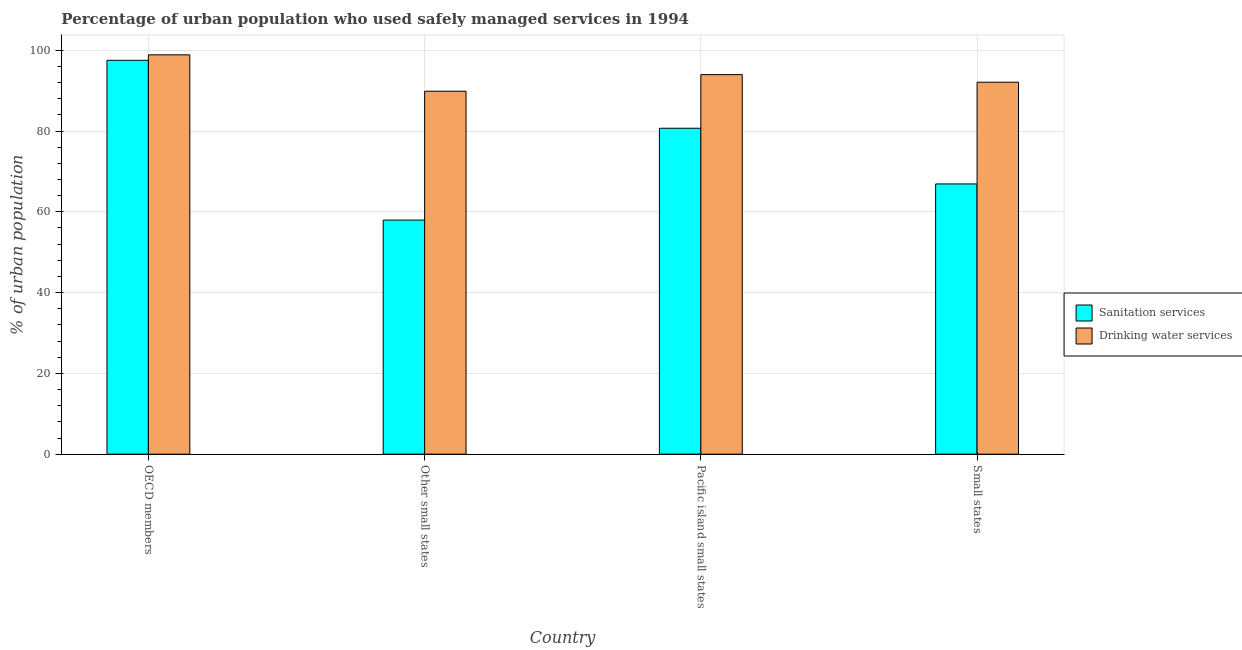Are the number of bars per tick equal to the number of legend labels?
Your answer should be very brief. Yes. Are the number of bars on each tick of the X-axis equal?
Provide a short and direct response. Yes. How many bars are there on the 4th tick from the right?
Provide a succinct answer. 2. What is the label of the 4th group of bars from the left?
Keep it short and to the point. Small states. What is the percentage of urban population who used sanitation services in Other small states?
Your response must be concise. 57.97. Across all countries, what is the maximum percentage of urban population who used drinking water services?
Ensure brevity in your answer.  98.88. Across all countries, what is the minimum percentage of urban population who used drinking water services?
Keep it short and to the point. 89.87. In which country was the percentage of urban population who used drinking water services minimum?
Your answer should be compact. Other small states. What is the total percentage of urban population who used sanitation services in the graph?
Your response must be concise. 303.1. What is the difference between the percentage of urban population who used drinking water services in Pacific island small states and that in Small states?
Give a very brief answer. 1.88. What is the difference between the percentage of urban population who used sanitation services in Small states and the percentage of urban population who used drinking water services in Pacific island small states?
Your answer should be very brief. -27.07. What is the average percentage of urban population who used drinking water services per country?
Make the answer very short. 93.71. What is the difference between the percentage of urban population who used drinking water services and percentage of urban population who used sanitation services in OECD members?
Offer a terse response. 1.35. In how many countries, is the percentage of urban population who used sanitation services greater than 60 %?
Provide a succinct answer. 3. What is the ratio of the percentage of urban population who used sanitation services in OECD members to that in Pacific island small states?
Offer a terse response. 1.21. Is the percentage of urban population who used sanitation services in Other small states less than that in Small states?
Make the answer very short. Yes. Is the difference between the percentage of urban population who used sanitation services in Pacific island small states and Small states greater than the difference between the percentage of urban population who used drinking water services in Pacific island small states and Small states?
Keep it short and to the point. Yes. What is the difference between the highest and the second highest percentage of urban population who used drinking water services?
Provide a succinct answer. 4.9. What is the difference between the highest and the lowest percentage of urban population who used drinking water services?
Give a very brief answer. 9. Is the sum of the percentage of urban population who used drinking water services in OECD members and Other small states greater than the maximum percentage of urban population who used sanitation services across all countries?
Ensure brevity in your answer.  Yes. What does the 2nd bar from the left in Small states represents?
Provide a succinct answer. Drinking water services. What does the 2nd bar from the right in Other small states represents?
Provide a short and direct response. Sanitation services. How many bars are there?
Provide a succinct answer. 8. Are all the bars in the graph horizontal?
Keep it short and to the point. No. How many countries are there in the graph?
Give a very brief answer. 4. Does the graph contain any zero values?
Keep it short and to the point. No. Does the graph contain grids?
Keep it short and to the point. Yes. What is the title of the graph?
Your answer should be very brief. Percentage of urban population who used safely managed services in 1994. What is the label or title of the Y-axis?
Your answer should be compact. % of urban population. What is the % of urban population in Sanitation services in OECD members?
Provide a short and direct response. 97.52. What is the % of urban population of Drinking water services in OECD members?
Make the answer very short. 98.88. What is the % of urban population in Sanitation services in Other small states?
Provide a short and direct response. 57.97. What is the % of urban population of Drinking water services in Other small states?
Offer a very short reply. 89.87. What is the % of urban population in Sanitation services in Pacific island small states?
Offer a very short reply. 80.7. What is the % of urban population in Drinking water services in Pacific island small states?
Offer a terse response. 93.98. What is the % of urban population of Sanitation services in Small states?
Provide a short and direct response. 66.91. What is the % of urban population in Drinking water services in Small states?
Provide a short and direct response. 92.1. Across all countries, what is the maximum % of urban population in Sanitation services?
Provide a succinct answer. 97.52. Across all countries, what is the maximum % of urban population of Drinking water services?
Give a very brief answer. 98.88. Across all countries, what is the minimum % of urban population of Sanitation services?
Give a very brief answer. 57.97. Across all countries, what is the minimum % of urban population in Drinking water services?
Keep it short and to the point. 89.87. What is the total % of urban population of Sanitation services in the graph?
Offer a very short reply. 303.1. What is the total % of urban population of Drinking water services in the graph?
Offer a very short reply. 374.82. What is the difference between the % of urban population of Sanitation services in OECD members and that in Other small states?
Your answer should be compact. 39.55. What is the difference between the % of urban population in Drinking water services in OECD members and that in Other small states?
Offer a terse response. 9. What is the difference between the % of urban population in Sanitation services in OECD members and that in Pacific island small states?
Your answer should be very brief. 16.82. What is the difference between the % of urban population of Drinking water services in OECD members and that in Pacific island small states?
Your response must be concise. 4.9. What is the difference between the % of urban population in Sanitation services in OECD members and that in Small states?
Provide a succinct answer. 30.61. What is the difference between the % of urban population of Drinking water services in OECD members and that in Small states?
Your response must be concise. 6.78. What is the difference between the % of urban population of Sanitation services in Other small states and that in Pacific island small states?
Keep it short and to the point. -22.73. What is the difference between the % of urban population in Drinking water services in Other small states and that in Pacific island small states?
Keep it short and to the point. -4.1. What is the difference between the % of urban population in Sanitation services in Other small states and that in Small states?
Make the answer very short. -8.94. What is the difference between the % of urban population of Drinking water services in Other small states and that in Small states?
Your answer should be very brief. -2.23. What is the difference between the % of urban population in Sanitation services in Pacific island small states and that in Small states?
Provide a short and direct response. 13.79. What is the difference between the % of urban population of Drinking water services in Pacific island small states and that in Small states?
Your response must be concise. 1.88. What is the difference between the % of urban population of Sanitation services in OECD members and the % of urban population of Drinking water services in Other small states?
Your response must be concise. 7.65. What is the difference between the % of urban population in Sanitation services in OECD members and the % of urban population in Drinking water services in Pacific island small states?
Provide a short and direct response. 3.55. What is the difference between the % of urban population in Sanitation services in OECD members and the % of urban population in Drinking water services in Small states?
Your answer should be very brief. 5.42. What is the difference between the % of urban population of Sanitation services in Other small states and the % of urban population of Drinking water services in Pacific island small states?
Give a very brief answer. -36.01. What is the difference between the % of urban population of Sanitation services in Other small states and the % of urban population of Drinking water services in Small states?
Provide a succinct answer. -34.13. What is the difference between the % of urban population of Sanitation services in Pacific island small states and the % of urban population of Drinking water services in Small states?
Provide a short and direct response. -11.4. What is the average % of urban population in Sanitation services per country?
Keep it short and to the point. 75.77. What is the average % of urban population of Drinking water services per country?
Provide a succinct answer. 93.71. What is the difference between the % of urban population in Sanitation services and % of urban population in Drinking water services in OECD members?
Offer a very short reply. -1.35. What is the difference between the % of urban population in Sanitation services and % of urban population in Drinking water services in Other small states?
Make the answer very short. -31.91. What is the difference between the % of urban population in Sanitation services and % of urban population in Drinking water services in Pacific island small states?
Keep it short and to the point. -13.27. What is the difference between the % of urban population in Sanitation services and % of urban population in Drinking water services in Small states?
Offer a very short reply. -25.19. What is the ratio of the % of urban population in Sanitation services in OECD members to that in Other small states?
Your answer should be compact. 1.68. What is the ratio of the % of urban population in Drinking water services in OECD members to that in Other small states?
Keep it short and to the point. 1.1. What is the ratio of the % of urban population in Sanitation services in OECD members to that in Pacific island small states?
Your answer should be very brief. 1.21. What is the ratio of the % of urban population in Drinking water services in OECD members to that in Pacific island small states?
Make the answer very short. 1.05. What is the ratio of the % of urban population of Sanitation services in OECD members to that in Small states?
Offer a terse response. 1.46. What is the ratio of the % of urban population in Drinking water services in OECD members to that in Small states?
Provide a short and direct response. 1.07. What is the ratio of the % of urban population in Sanitation services in Other small states to that in Pacific island small states?
Offer a terse response. 0.72. What is the ratio of the % of urban population of Drinking water services in Other small states to that in Pacific island small states?
Give a very brief answer. 0.96. What is the ratio of the % of urban population of Sanitation services in Other small states to that in Small states?
Provide a succinct answer. 0.87. What is the ratio of the % of urban population in Drinking water services in Other small states to that in Small states?
Provide a succinct answer. 0.98. What is the ratio of the % of urban population of Sanitation services in Pacific island small states to that in Small states?
Keep it short and to the point. 1.21. What is the ratio of the % of urban population in Drinking water services in Pacific island small states to that in Small states?
Provide a succinct answer. 1.02. What is the difference between the highest and the second highest % of urban population in Sanitation services?
Make the answer very short. 16.82. What is the difference between the highest and the second highest % of urban population of Drinking water services?
Your answer should be very brief. 4.9. What is the difference between the highest and the lowest % of urban population of Sanitation services?
Your answer should be compact. 39.55. What is the difference between the highest and the lowest % of urban population in Drinking water services?
Ensure brevity in your answer.  9. 